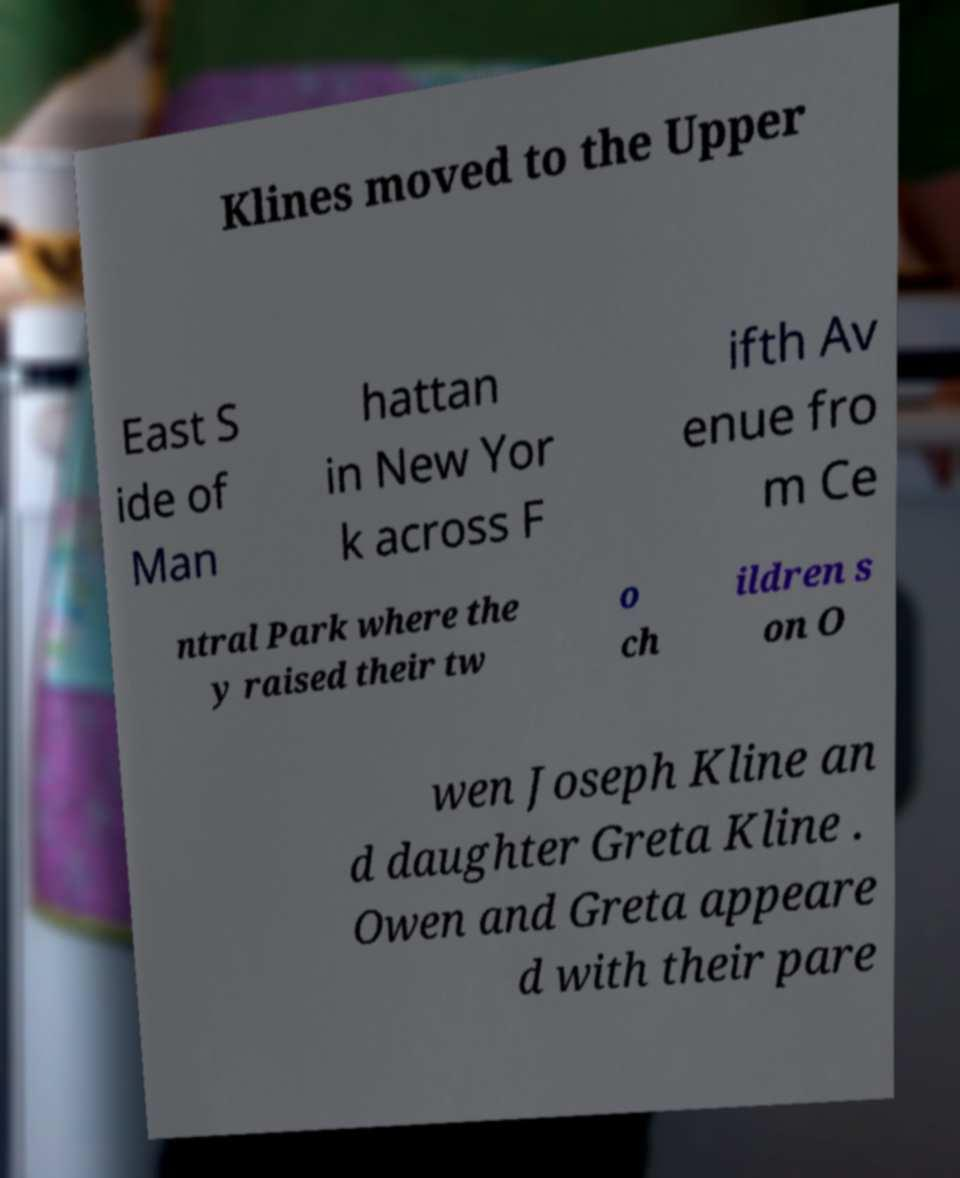Please read and relay the text visible in this image. What does it say? Klines moved to the Upper East S ide of Man hattan in New Yor k across F ifth Av enue fro m Ce ntral Park where the y raised their tw o ch ildren s on O wen Joseph Kline an d daughter Greta Kline . Owen and Greta appeare d with their pare 